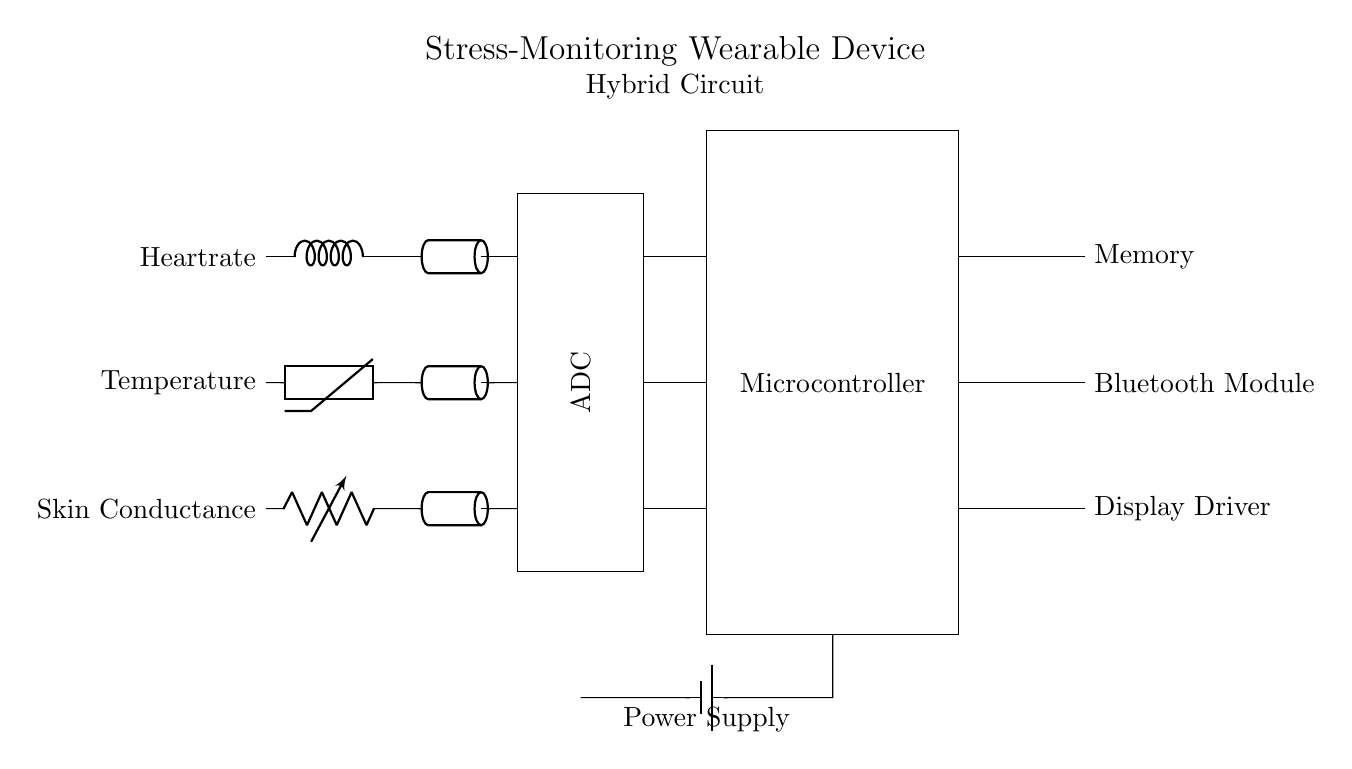What are the analog sensors used in this circuit? The circuit includes heart rate, temperature, and skin conductance sensors, which are clearly labeled in the diagram.
Answer: heart rate, temperature, skin conductance What is the role of the ADC in this circuit? The ADC (Analog to Digital Converter) is responsible for converting the analog signals from the sensors into digital data for processing by the microcontroller.
Answer: converting analog signals Which component connects to the memory? The memory is directly connected to the microcontroller, as shown by the line indicating a connection from the microcontroller to the memory block.
Answer: microcontroller How many analog sensors are shown in the diagram? There are three analog sensors depicted in the circuit, which are indicated by the components and their labels.
Answer: three What type of power supply is indicated in the circuit? The circuit uses a battery as indicated by the battery symbol that provides the necessary power supply to the components.
Answer: battery What is the function of the Bluetooth module in this circuit? The Bluetooth module allows for wireless communication and data transfer between the wearable device and other devices, which is crucial for monitoring stress data.
Answer: wireless communication Why is a microcontroller included in this hybrid circuit? The microcontroller processes the digital data from the ADC and controls other components, making it essential for the functionality of the stress-monitoring wearable device.
Answer: data processing and control 